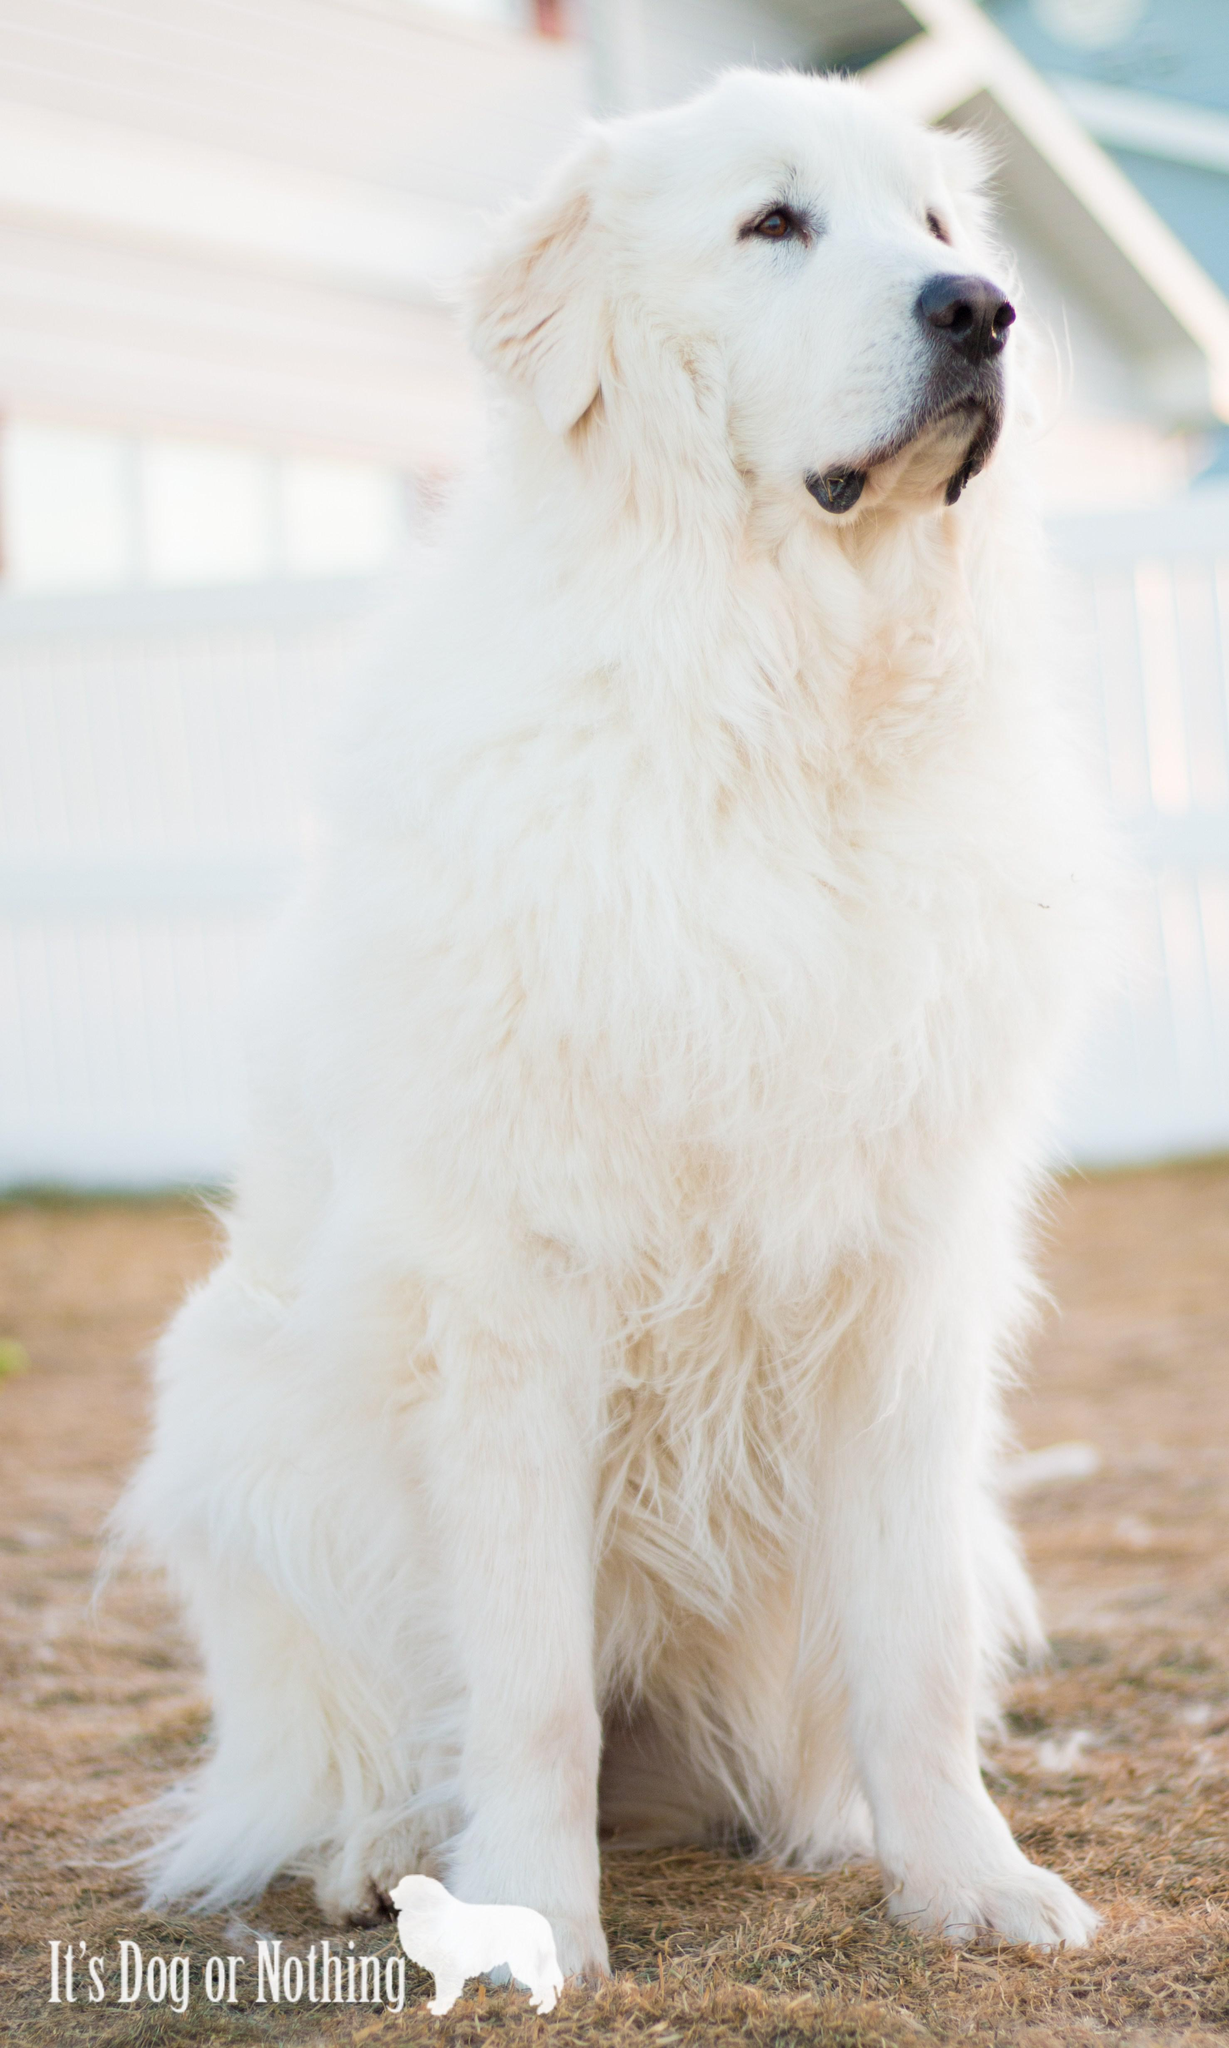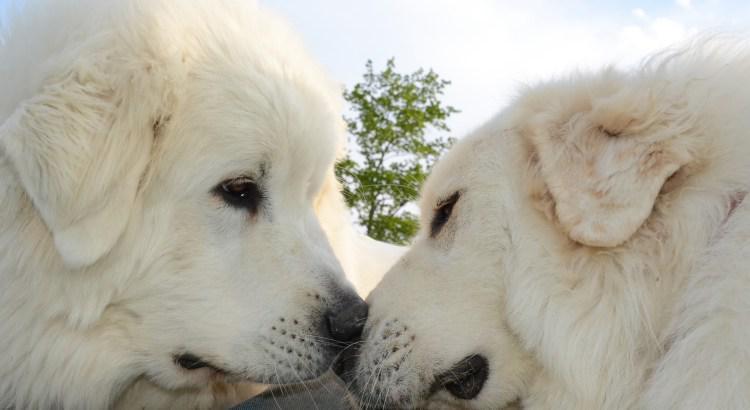The first image is the image on the left, the second image is the image on the right. Assess this claim about the two images: "There is a dog standing in snow in the images.". Correct or not? Answer yes or no. No. 